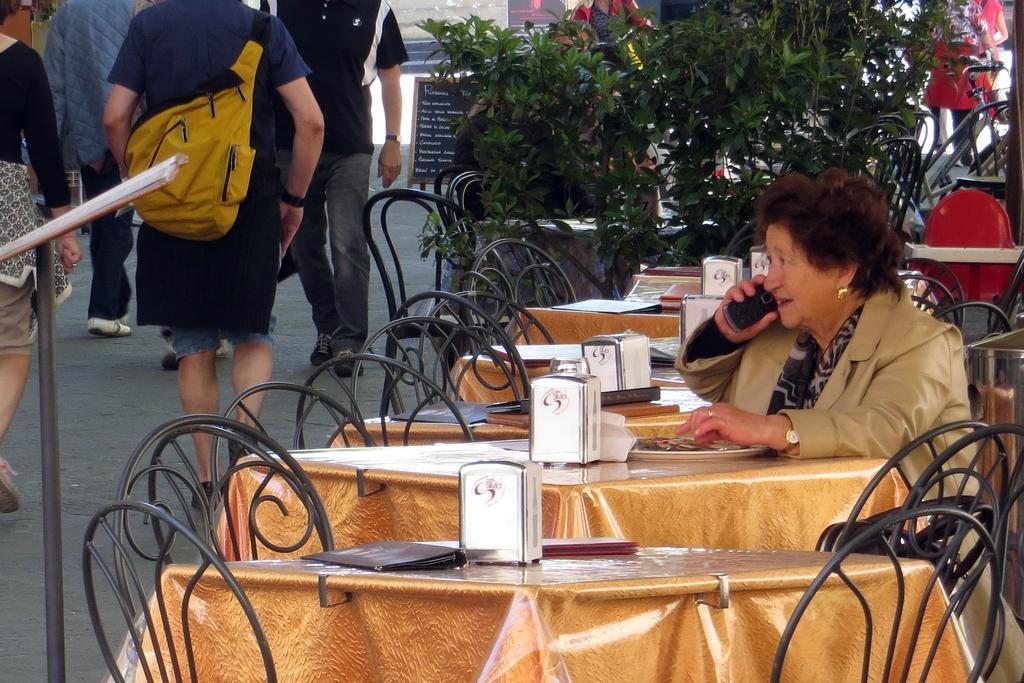In one or two sentences, can you explain what this image depicts? In this picture we can see one women sitting on a chair in front of a table and she is on a call. We can plants and few persons walking on the road. This is a board. 